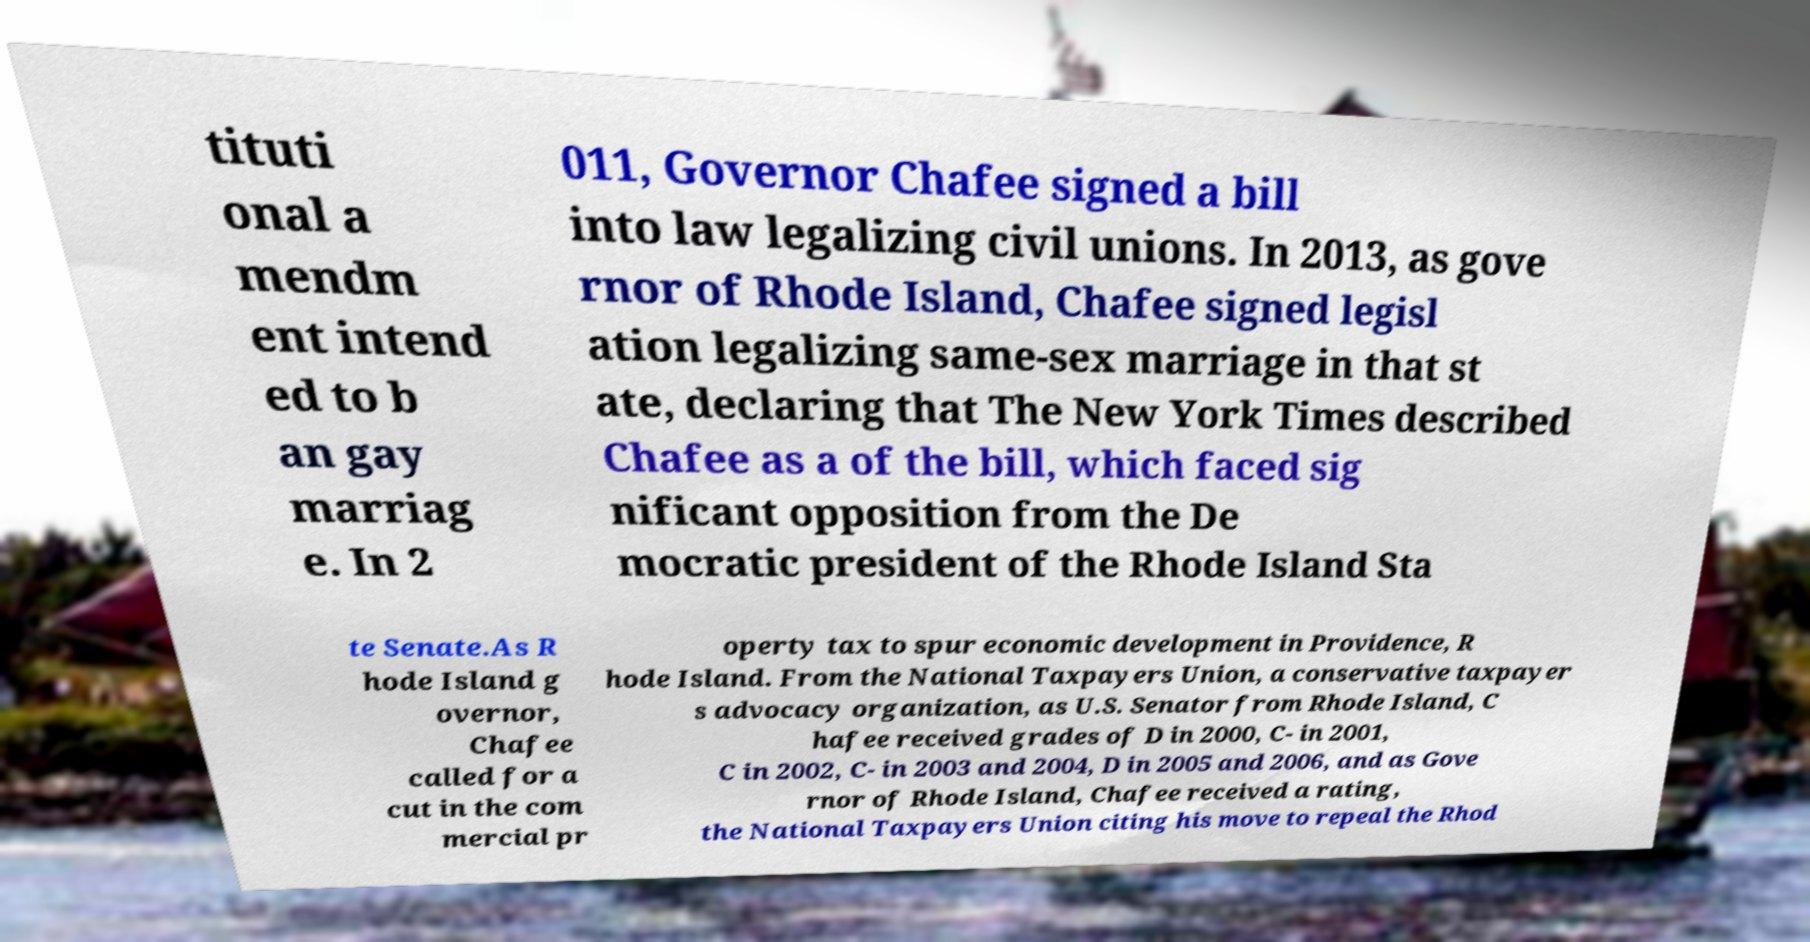Please read and relay the text visible in this image. What does it say? tituti onal a mendm ent intend ed to b an gay marriag e. In 2 011, Governor Chafee signed a bill into law legalizing civil unions. In 2013, as gove rnor of Rhode Island, Chafee signed legisl ation legalizing same-sex marriage in that st ate, declaring that The New York Times described Chafee as a of the bill, which faced sig nificant opposition from the De mocratic president of the Rhode Island Sta te Senate.As R hode Island g overnor, Chafee called for a cut in the com mercial pr operty tax to spur economic development in Providence, R hode Island. From the National Taxpayers Union, a conservative taxpayer s advocacy organization, as U.S. Senator from Rhode Island, C hafee received grades of D in 2000, C- in 2001, C in 2002, C- in 2003 and 2004, D in 2005 and 2006, and as Gove rnor of Rhode Island, Chafee received a rating, the National Taxpayers Union citing his move to repeal the Rhod 